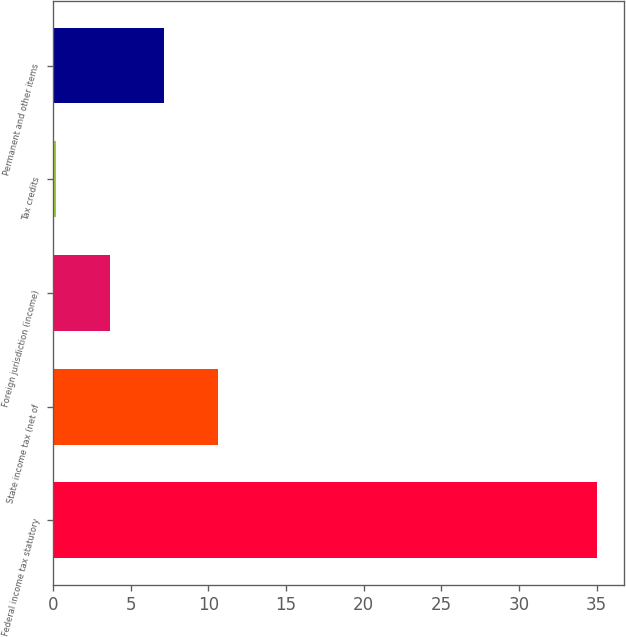<chart> <loc_0><loc_0><loc_500><loc_500><bar_chart><fcel>Federal income tax statutory<fcel>State income tax (net of<fcel>Foreign jurisdiction (income)<fcel>Tax credits<fcel>Permanent and other items<nl><fcel>35<fcel>10.64<fcel>3.68<fcel>0.2<fcel>7.16<nl></chart> 